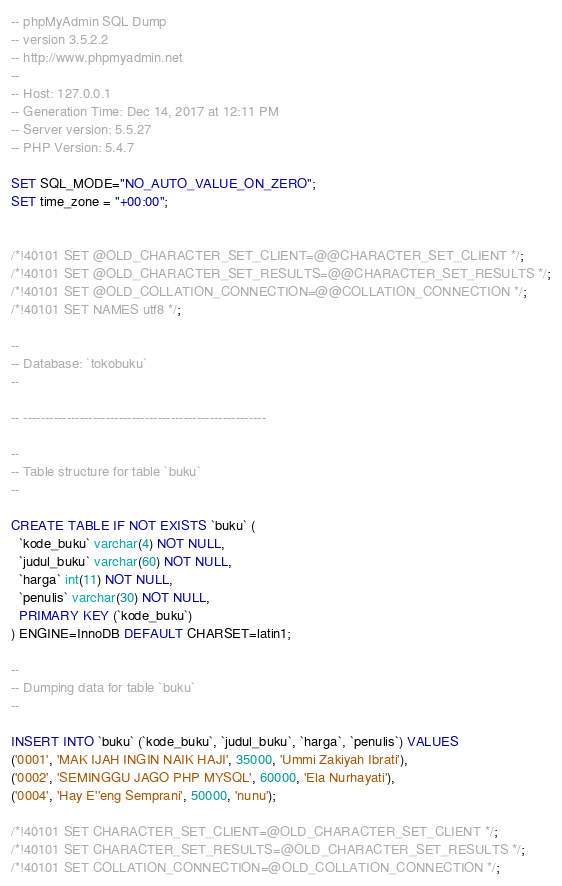Convert code to text. <code><loc_0><loc_0><loc_500><loc_500><_SQL_>-- phpMyAdmin SQL Dump
-- version 3.5.2.2
-- http://www.phpmyadmin.net
--
-- Host: 127.0.0.1
-- Generation Time: Dec 14, 2017 at 12:11 PM
-- Server version: 5.5.27
-- PHP Version: 5.4.7

SET SQL_MODE="NO_AUTO_VALUE_ON_ZERO";
SET time_zone = "+00:00";


/*!40101 SET @OLD_CHARACTER_SET_CLIENT=@@CHARACTER_SET_CLIENT */;
/*!40101 SET @OLD_CHARACTER_SET_RESULTS=@@CHARACTER_SET_RESULTS */;
/*!40101 SET @OLD_COLLATION_CONNECTION=@@COLLATION_CONNECTION */;
/*!40101 SET NAMES utf8 */;

--
-- Database: `tokobuku`
--

-- --------------------------------------------------------

--
-- Table structure for table `buku`
--

CREATE TABLE IF NOT EXISTS `buku` (
  `kode_buku` varchar(4) NOT NULL,
  `judul_buku` varchar(60) NOT NULL,
  `harga` int(11) NOT NULL,
  `penulis` varchar(30) NOT NULL,
  PRIMARY KEY (`kode_buku`)
) ENGINE=InnoDB DEFAULT CHARSET=latin1;

--
-- Dumping data for table `buku`
--

INSERT INTO `buku` (`kode_buku`, `judul_buku`, `harga`, `penulis`) VALUES
('0001', 'MAK IJAH INGIN NAIK HAJI', 35000, 'Ummi Zakiyah Ibrati'),
('0002', 'SEMINGGU JAGO PHP MYSQL', 60000, 'Ela Nurhayati'),
('0004', 'Hay E''eng Semprani', 50000, 'nunu');

/*!40101 SET CHARACTER_SET_CLIENT=@OLD_CHARACTER_SET_CLIENT */;
/*!40101 SET CHARACTER_SET_RESULTS=@OLD_CHARACTER_SET_RESULTS */;
/*!40101 SET COLLATION_CONNECTION=@OLD_COLLATION_CONNECTION */;
</code> 